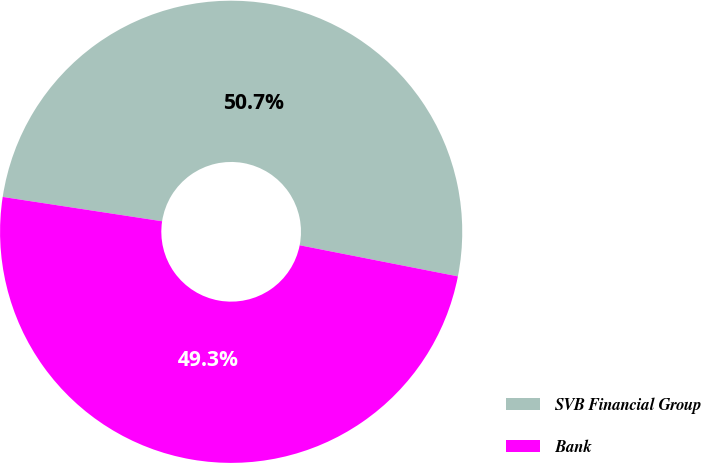Convert chart to OTSL. <chart><loc_0><loc_0><loc_500><loc_500><pie_chart><fcel>SVB Financial Group<fcel>Bank<nl><fcel>50.68%<fcel>49.32%<nl></chart> 